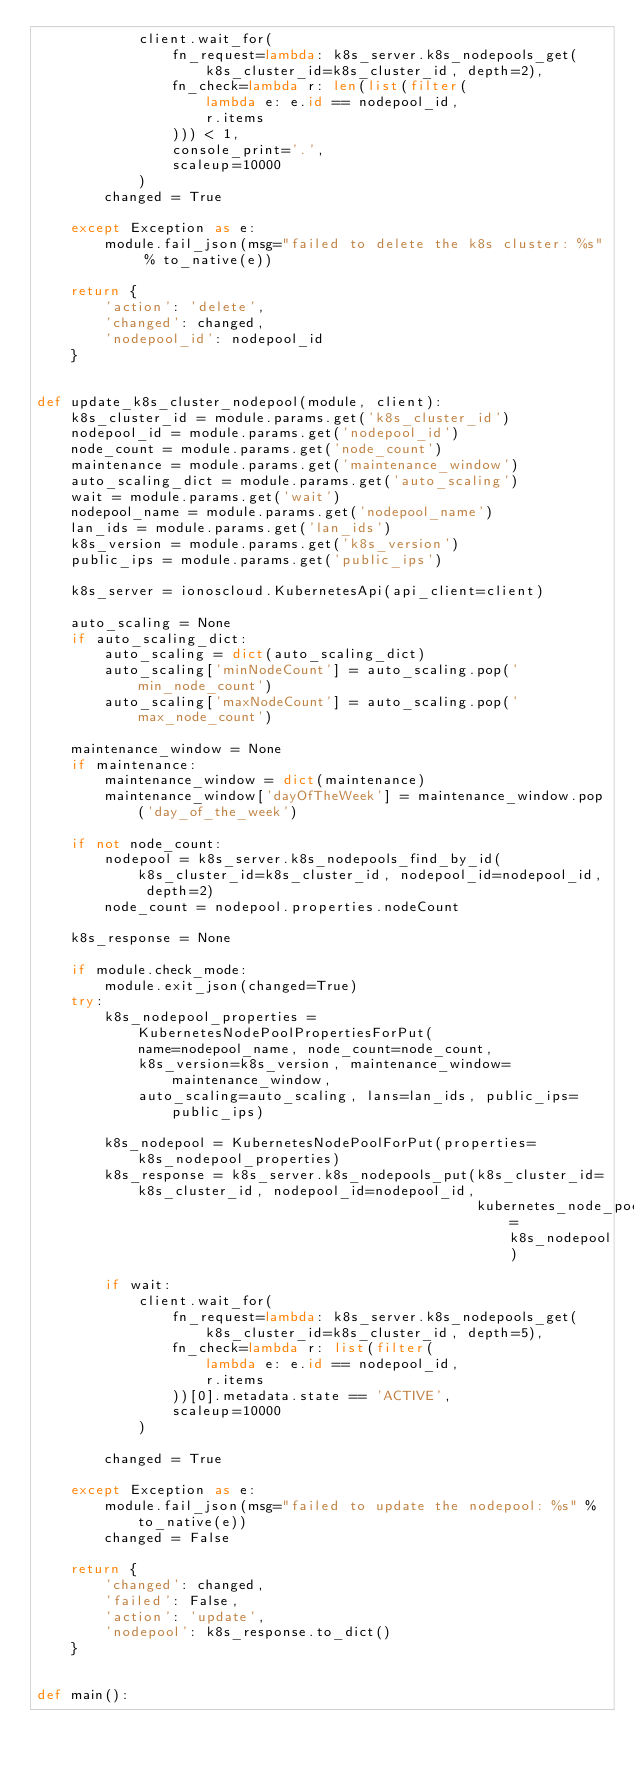<code> <loc_0><loc_0><loc_500><loc_500><_Python_>            client.wait_for(
                fn_request=lambda: k8s_server.k8s_nodepools_get(k8s_cluster_id=k8s_cluster_id, depth=2),
                fn_check=lambda r: len(list(filter(
                    lambda e: e.id == nodepool_id,
                    r.items
                ))) < 1,
                console_print='.',
                scaleup=10000
            )
        changed = True

    except Exception as e:
        module.fail_json(msg="failed to delete the k8s cluster: %s" % to_native(e))

    return {
        'action': 'delete',
        'changed': changed,
        'nodepool_id': nodepool_id
    }


def update_k8s_cluster_nodepool(module, client):
    k8s_cluster_id = module.params.get('k8s_cluster_id')
    nodepool_id = module.params.get('nodepool_id')
    node_count = module.params.get('node_count')
    maintenance = module.params.get('maintenance_window')
    auto_scaling_dict = module.params.get('auto_scaling')
    wait = module.params.get('wait')
    nodepool_name = module.params.get('nodepool_name')
    lan_ids = module.params.get('lan_ids')
    k8s_version = module.params.get('k8s_version')
    public_ips = module.params.get('public_ips')

    k8s_server = ionoscloud.KubernetesApi(api_client=client)

    auto_scaling = None
    if auto_scaling_dict:
        auto_scaling = dict(auto_scaling_dict)
        auto_scaling['minNodeCount'] = auto_scaling.pop('min_node_count')
        auto_scaling['maxNodeCount'] = auto_scaling.pop('max_node_count')

    maintenance_window = None
    if maintenance:
        maintenance_window = dict(maintenance)
        maintenance_window['dayOfTheWeek'] = maintenance_window.pop('day_of_the_week')

    if not node_count:
        nodepool = k8s_server.k8s_nodepools_find_by_id(k8s_cluster_id=k8s_cluster_id, nodepool_id=nodepool_id, depth=2)
        node_count = nodepool.properties.nodeCount

    k8s_response = None

    if module.check_mode:
        module.exit_json(changed=True)
    try:
        k8s_nodepool_properties = KubernetesNodePoolPropertiesForPut(
            name=nodepool_name, node_count=node_count,
            k8s_version=k8s_version, maintenance_window=maintenance_window,
            auto_scaling=auto_scaling, lans=lan_ids, public_ips=public_ips)

        k8s_nodepool = KubernetesNodePoolForPut(properties=k8s_nodepool_properties)
        k8s_response = k8s_server.k8s_nodepools_put(k8s_cluster_id=k8s_cluster_id, nodepool_id=nodepool_id,
                                                    kubernetes_node_pool=k8s_nodepool)

        if wait:
            client.wait_for(
                fn_request=lambda: k8s_server.k8s_nodepools_get(k8s_cluster_id=k8s_cluster_id, depth=5),
                fn_check=lambda r: list(filter(
                    lambda e: e.id == nodepool_id,
                    r.items
                ))[0].metadata.state == 'ACTIVE',
                scaleup=10000
            )

        changed = True

    except Exception as e:
        module.fail_json(msg="failed to update the nodepool: %s" % to_native(e))
        changed = False

    return {
        'changed': changed,
        'failed': False,
        'action': 'update',
        'nodepool': k8s_response.to_dict()
    }


def main():</code> 